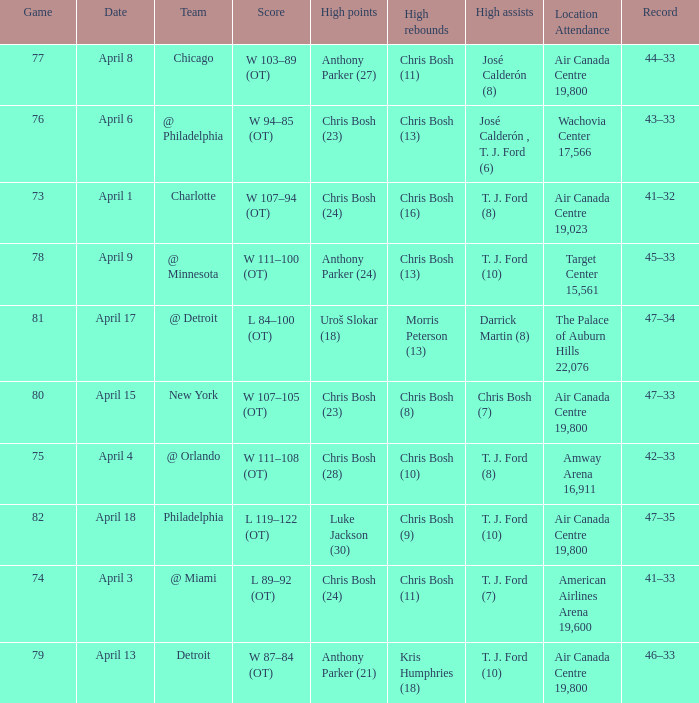What was the score of game 82? L 119–122 (OT). 